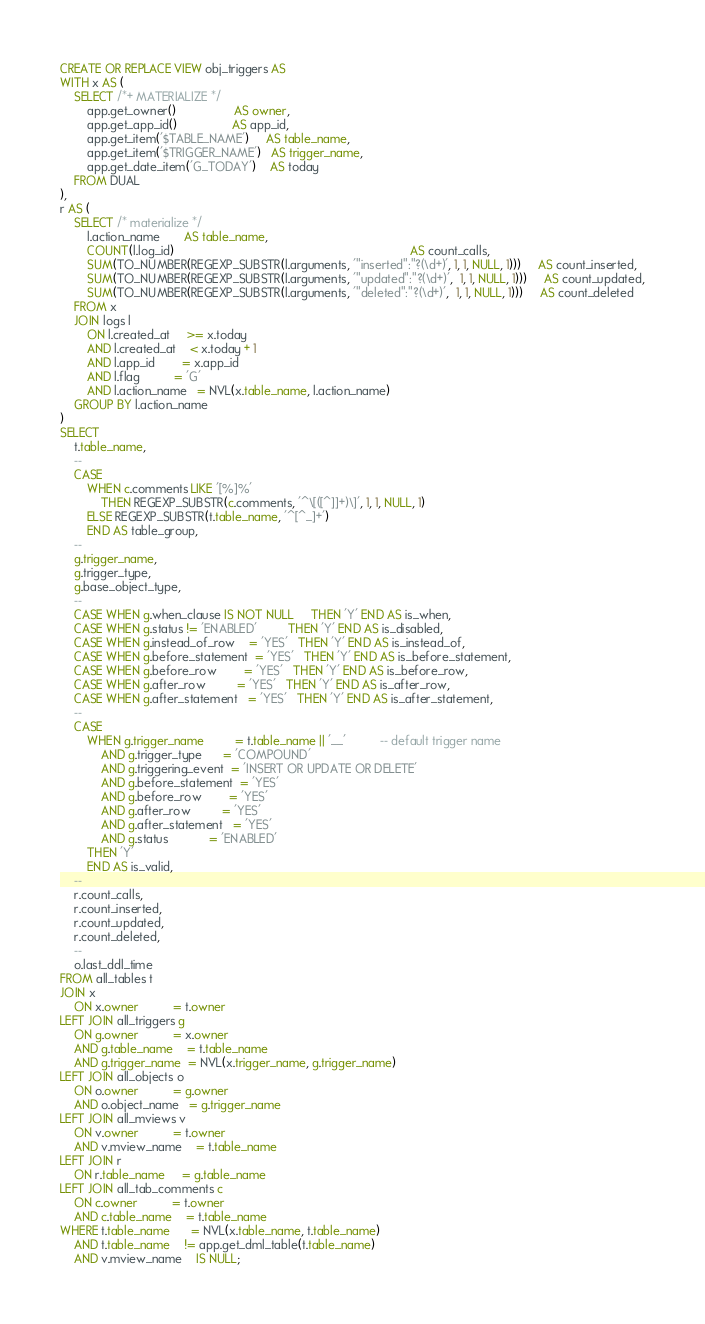<code> <loc_0><loc_0><loc_500><loc_500><_SQL_>CREATE OR REPLACE VIEW obj_triggers AS
WITH x AS (
    SELECT /*+ MATERIALIZE */
        app.get_owner()                 AS owner,
        app.get_app_id()                AS app_id,
        app.get_item('$TABLE_NAME')     AS table_name,
        app.get_item('$TRIGGER_NAME')   AS trigger_name,
        app.get_date_item('G_TODAY')    AS today
    FROM DUAL
),
r AS (
    SELECT /* materialize */
        l.action_name       AS table_name,
        COUNT(l.log_id)                                                                     AS count_calls,
        SUM(TO_NUMBER(REGEXP_SUBSTR(l.arguments, '"inserted":"?(\d+)', 1, 1, NULL, 1)))     AS count_inserted,
        SUM(TO_NUMBER(REGEXP_SUBSTR(l.arguments, '"updated":"?(\d+)',  1, 1, NULL, 1)))     AS count_updated,
        SUM(TO_NUMBER(REGEXP_SUBSTR(l.arguments, '"deleted":"?(\d+)',  1, 1, NULL, 1)))     AS count_deleted
    FROM x
    JOIN logs l
        ON l.created_at     >= x.today
        AND l.created_at    < x.today + 1
        AND l.app_id        = x.app_id
        AND l.flag          = 'G'
        AND l.action_name   = NVL(x.table_name, l.action_name)
    GROUP BY l.action_name
)
SELECT
    t.table_name,
    --
    CASE
        WHEN c.comments LIKE '[%]%'
            THEN REGEXP_SUBSTR(c.comments, '^\[([^]]+)\]', 1, 1, NULL, 1)
        ELSE REGEXP_SUBSTR(t.table_name, '^[^_]+')
        END AS table_group,
    --
    g.trigger_name,
    g.trigger_type,
    g.base_object_type,
    --
    CASE WHEN g.when_clause IS NOT NULL     THEN 'Y' END AS is_when,
    CASE WHEN g.status != 'ENABLED'         THEN 'Y' END AS is_disabled,
    CASE WHEN g.instead_of_row    = 'YES'   THEN 'Y' END AS is_instead_of,
    CASE WHEN g.before_statement  = 'YES'   THEN 'Y' END AS is_before_statement,
    CASE WHEN g.before_row        = 'YES'   THEN 'Y' END AS is_before_row,
    CASE WHEN g.after_row         = 'YES'   THEN 'Y' END AS is_after_row,
    CASE WHEN g.after_statement   = 'YES'   THEN 'Y' END AS is_after_statement,
    --
    CASE
        WHEN g.trigger_name         = t.table_name || '__'          -- default trigger name
            AND g.trigger_type      = 'COMPOUND'
            AND g.triggering_event  = 'INSERT OR UPDATE OR DELETE'
            AND g.before_statement  = 'YES'
            AND g.before_row        = 'YES'
            AND g.after_row         = 'YES'
            AND g.after_statement   = 'YES'
            AND g.status            = 'ENABLED'
        THEN 'Y'
        END AS is_valid,
    --
    r.count_calls,
    r.count_inserted,
    r.count_updated,
    r.count_deleted,
    --
    o.last_ddl_time
FROM all_tables t
JOIN x
    ON x.owner          = t.owner
LEFT JOIN all_triggers g
    ON g.owner          = x.owner
    AND g.table_name    = t.table_name
    AND g.trigger_name  = NVL(x.trigger_name, g.trigger_name)
LEFT JOIN all_objects o
    ON o.owner          = g.owner
    AND o.object_name   = g.trigger_name
LEFT JOIN all_mviews v
    ON v.owner          = t.owner
    AND v.mview_name    = t.table_name
LEFT JOIN r
    ON r.table_name     = g.table_name
LEFT JOIN all_tab_comments c
    ON c.owner          = t.owner
    AND c.table_name    = t.table_name
WHERE t.table_name      = NVL(x.table_name, t.table_name)
    AND t.table_name    != app.get_dml_table(t.table_name)
    AND v.mview_name    IS NULL;

</code> 